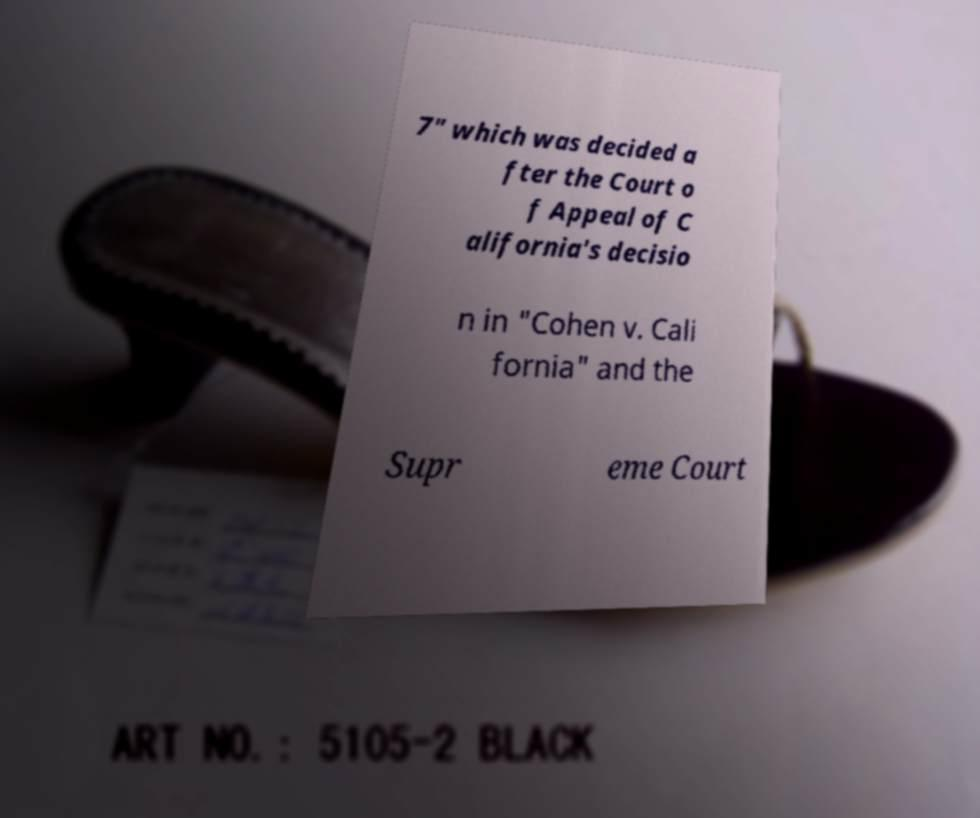Please identify and transcribe the text found in this image. 7" which was decided a fter the Court o f Appeal of C alifornia's decisio n in "Cohen v. Cali fornia" and the Supr eme Court 